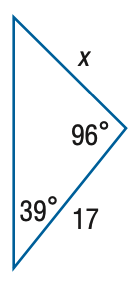Answer the mathemtical geometry problem and directly provide the correct option letter.
Question: Find x. Round side measure to the nearest tenth.
Choices: A: 10.8 B: 15.1 C: 19.1 D: 26.9 B 